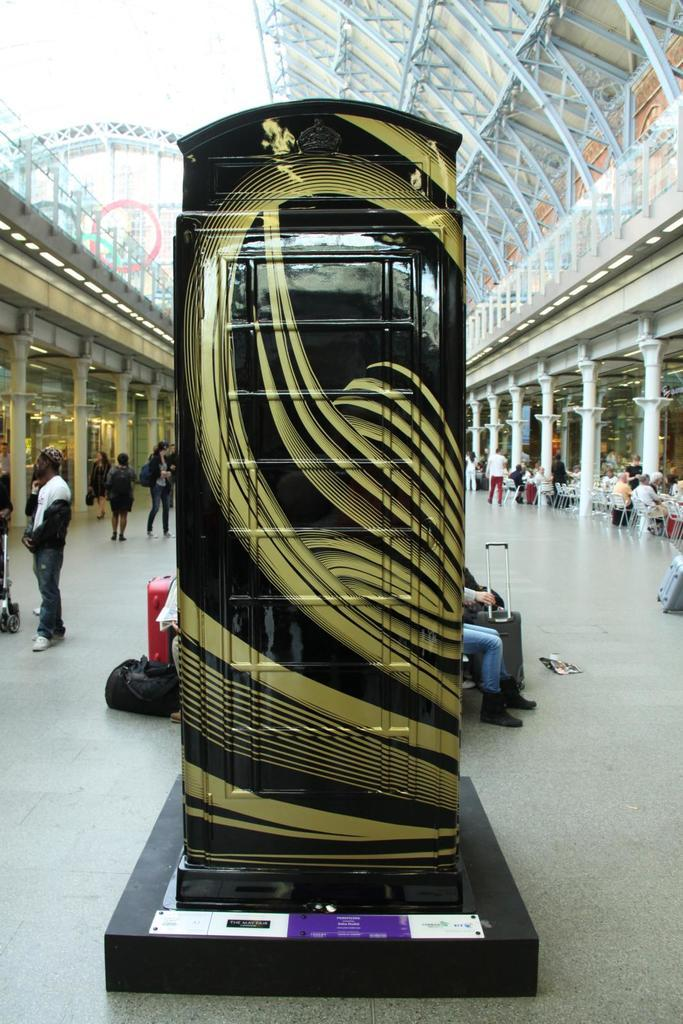Who is the main subject on the left side of the image? There is a man standing on the left side of the image. What are the people in the image doing? The people in the image are walking. How many sheep can be seen in the image? There are no sheep present in the image. What type of sport is being played in the image? There is no sport being played in the image. What is the level of respect shown by the people in the image? The level of respect shown by the people in the image cannot be determined from the image alone. 